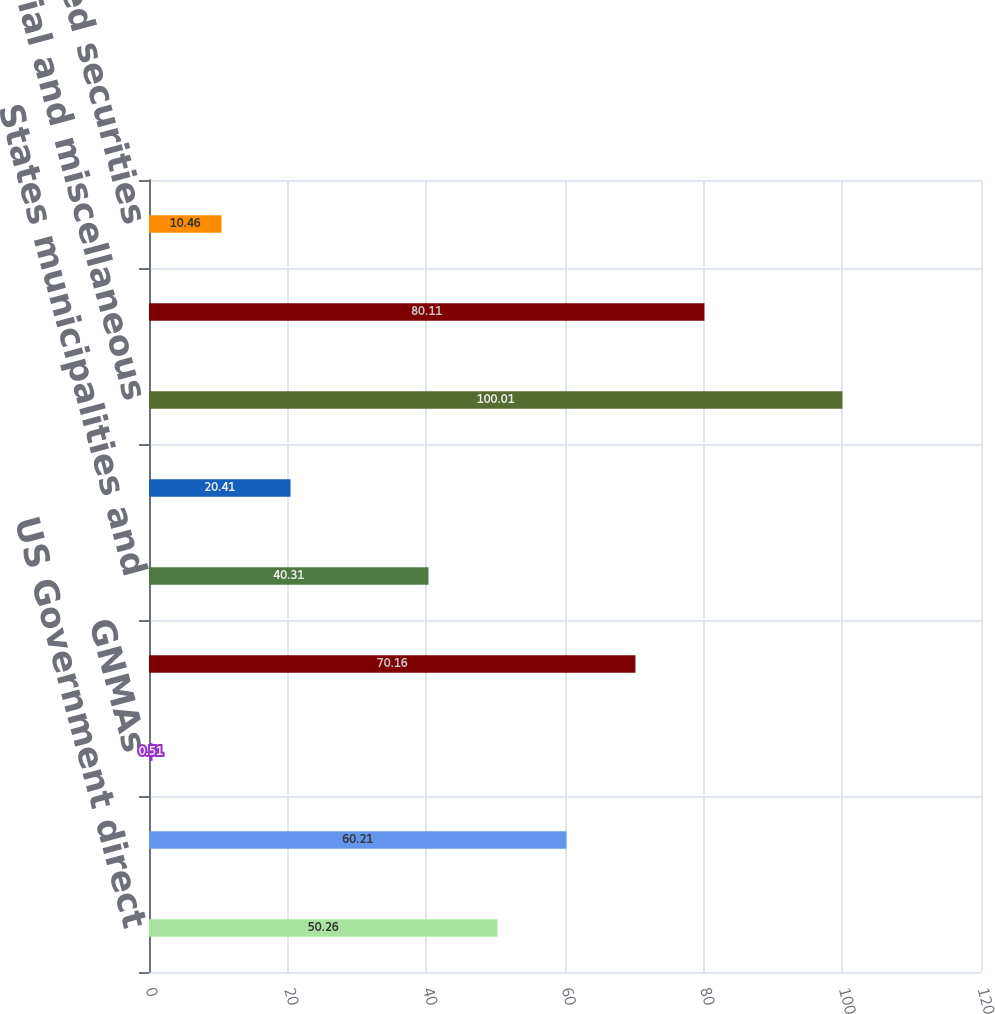Convert chart to OTSL. <chart><loc_0><loc_0><loc_500><loc_500><bar_chart><fcel>US Government direct<fcel>Government-sponsored<fcel>GNMAs<fcel>Other mortgage-backed<fcel>States municipalities and<fcel>Foreign governments<fcel>Industrial and miscellaneous<fcel>Public utilities<fcel>Asset-backed securities<nl><fcel>50.26<fcel>60.21<fcel>0.51<fcel>70.16<fcel>40.31<fcel>20.41<fcel>100.01<fcel>80.11<fcel>10.46<nl></chart> 